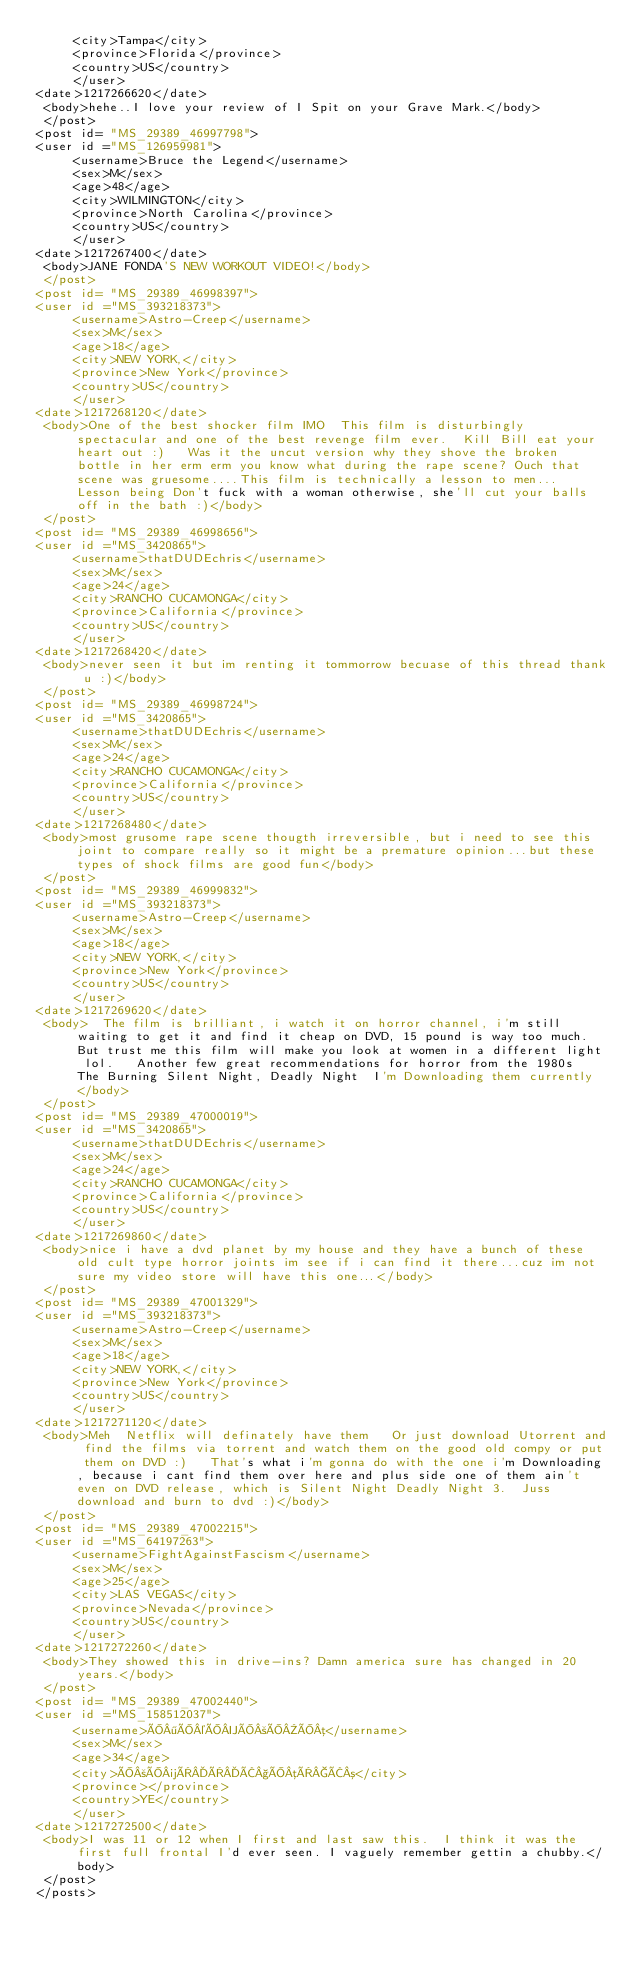Convert code to text. <code><loc_0><loc_0><loc_500><loc_500><_XML_>	 <city>Tampa</city> 
	 <province>Florida</province> 
	 <country>US</country> 
	 </user> 
<date>1217266620</date> 
 <body>hehe..I love your review of I Spit on your Grave Mark.</body> 
 </post> 
<post id= "MS_29389_46997798"> 
<user id ="MS_126959981"> 
	 <username>Bruce the Legend</username> 
	 <sex>M</sex> 
	 <age>48</age> 
	 <city>WILMINGTON</city> 
	 <province>North Carolina</province> 
	 <country>US</country> 
	 </user> 
<date>1217267400</date> 
 <body>JANE FONDA'S NEW WORKOUT VIDEO!</body> 
 </post> 
<post id= "MS_29389_46998397"> 
<user id ="MS_393218373"> 
	 <username>Astro-Creep</username> 
	 <sex>M</sex> 
	 <age>18</age> 
	 <city>NEW YORK,</city> 
	 <province>New York</province> 
	 <country>US</country> 
	 </user> 
<date>1217268120</date> 
 <body>One of the best shocker film IMO  This film is disturbingly spectacular and one of the best revenge film ever.  Kill Bill eat your heart out :)   Was it the uncut version why they shove the broken bottle in her erm erm you know what during the rape scene? Ouch that scene was gruesome....This film is technically a lesson to men...  Lesson being Don't fuck with a woman otherwise, she'll cut your balls off in the bath :)</body> 
 </post> 
<post id= "MS_29389_46998656"> 
<user id ="MS_3420865"> 
	 <username>thatDUDEchris</username> 
	 <sex>M</sex> 
	 <age>24</age> 
	 <city>RANCHO CUCAMONGA</city> 
	 <province>California</province> 
	 <country>US</country> 
	 </user> 
<date>1217268420</date> 
 <body>never seen it but im renting it tommorrow becuase of this thread thank u :)</body> 
 </post> 
<post id= "MS_29389_46998724"> 
<user id ="MS_3420865"> 
	 <username>thatDUDEchris</username> 
	 <sex>M</sex> 
	 <age>24</age> 
	 <city>RANCHO CUCAMONGA</city> 
	 <province>California</province> 
	 <country>US</country> 
	 </user> 
<date>1217268480</date> 
 <body>most grusome rape scene thougth irreversible, but i need to see this joint to compare really so it might be a premature opinion...but these types of shock films are good fun</body> 
 </post> 
<post id= "MS_29389_46999832"> 
<user id ="MS_393218373"> 
	 <username>Astro-Creep</username> 
	 <sex>M</sex> 
	 <age>18</age> 
	 <city>NEW YORK,</city> 
	 <province>New York</province> 
	 <country>US</country> 
	 </user> 
<date>1217269620</date> 
 <body>  The film is brilliant, i watch it on horror channel, i'm still waiting to get it and find it cheap on DVD, 15 pound is way too much. But trust me this film will make you look at women in a different light lol.   Another few great recommendations for horror from the 1980s  The Burning Silent Night, Deadly Night  I'm Downloading them currently</body> 
 </post> 
<post id= "MS_29389_47000019"> 
<user id ="MS_3420865"> 
	 <username>thatDUDEchris</username> 
	 <sex>M</sex> 
	 <age>24</age> 
	 <city>RANCHO CUCAMONGA</city> 
	 <province>California</province> 
	 <country>US</country> 
	 </user> 
<date>1217269860</date> 
 <body>nice i have a dvd planet by my house and they have a bunch of these old cult type horror joints im see if i can find it there...cuz im not sure my video store will have this one...</body> 
 </post> 
<post id= "MS_29389_47001329"> 
<user id ="MS_393218373"> 
	 <username>Astro-Creep</username> 
	 <sex>M</sex> 
	 <age>18</age> 
	 <city>NEW YORK,</city> 
	 <province>New York</province> 
	 <country>US</country> 
	 </user> 
<date>1217271120</date> 
 <body>Meh  Netflix will definately have them   Or just download Utorrent and find the films via torrent and watch them on the good old compy or put them on DVD :)   That's what i'm gonna do with the one i'm Downloading, because i cant find them over here and plus side one of them ain't even on DVD release, which is Silent Night Deadly Night 3.  Juss download and burn to dvd :)</body> 
 </post> 
<post id= "MS_29389_47002215"> 
<user id ="MS_64197263"> 
	 <username>FightAgainstFascism</username> 
	 <sex>M</sex> 
	 <age>25</age> 
	 <city>LAS VEGAS</city> 
	 <province>Nevada</province> 
	 <country>US</country> 
	 </user> 
<date>1217272260</date> 
 <body>They showed this in drive-ins? Damn america sure has changed in 20 years.</body> 
 </post> 
<post id= "MS_29389_47002440"> 
<user id ="MS_158512037"> 
	 <username>Î¶Î©ÎÎ²ÎÎµ</username> 
	 <sex>M</sex> 
	 <age>34</age> 
	 <city>Î²Î¼ÏÏÂ§ÎµÏÂ³</city> 
	 <province></province> 
	 <country>YE</country> 
	 </user> 
<date>1217272500</date> 
 <body>I was 11 or 12 when I first and last saw this.  I think it was the first full frontal I'd ever seen. I vaguely remember gettin a chubby.</body> 
 </post> 
</posts></code> 